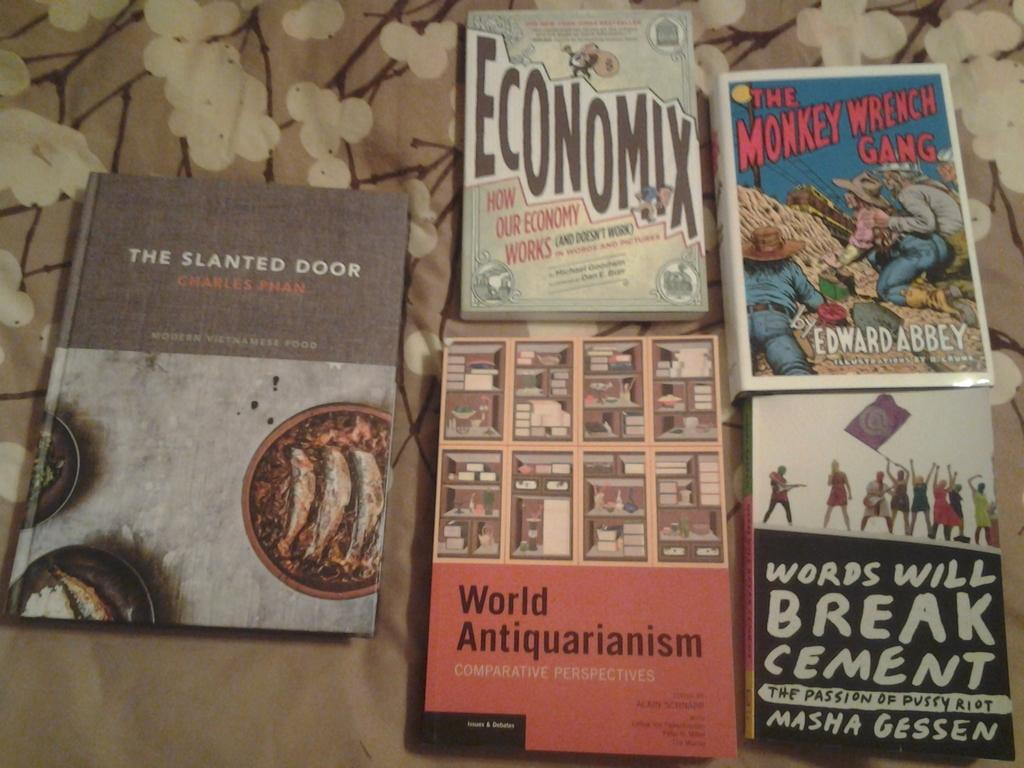How many books are visible in the image? There are five books in the image. What can be seen on the covers of two of the books? Two of the books have depictions of persons on their covers. What is written or printed on the books? There is text on the books. What is located at the bottom of the image? There is a cloth at the bottom of the image. What type of meal is being prepared on the books in the image? There is no meal being prepared on the books in the image; they are simply books with text and depictions of persons. 